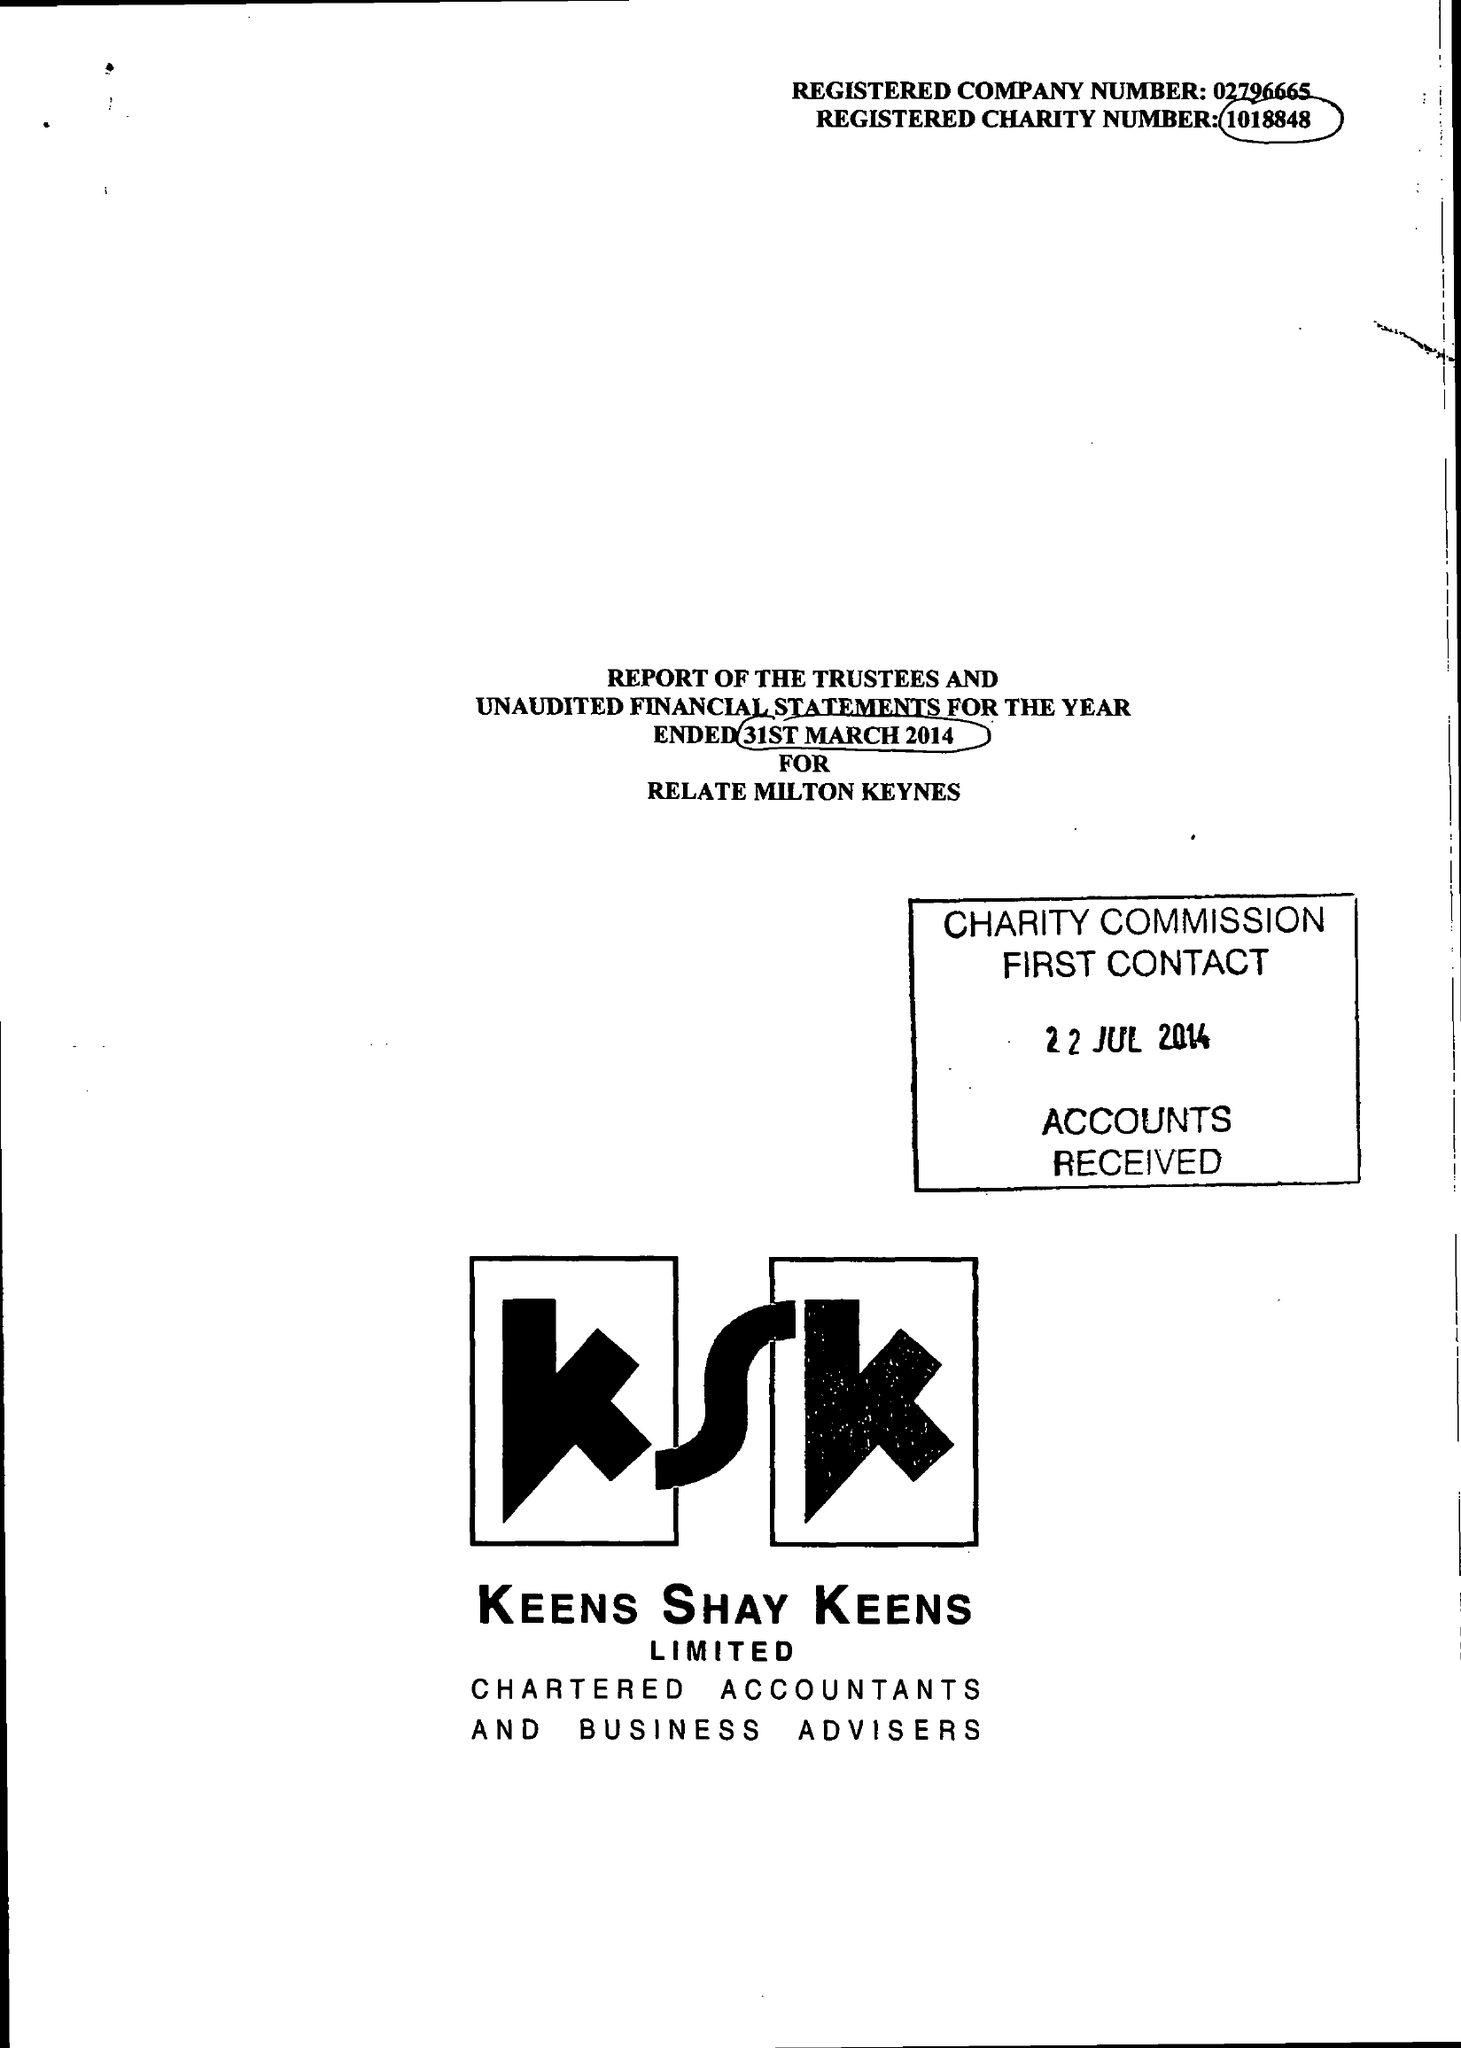What is the value for the charity_name?
Answer the question using a single word or phrase. Relate (Milton Keynes) 